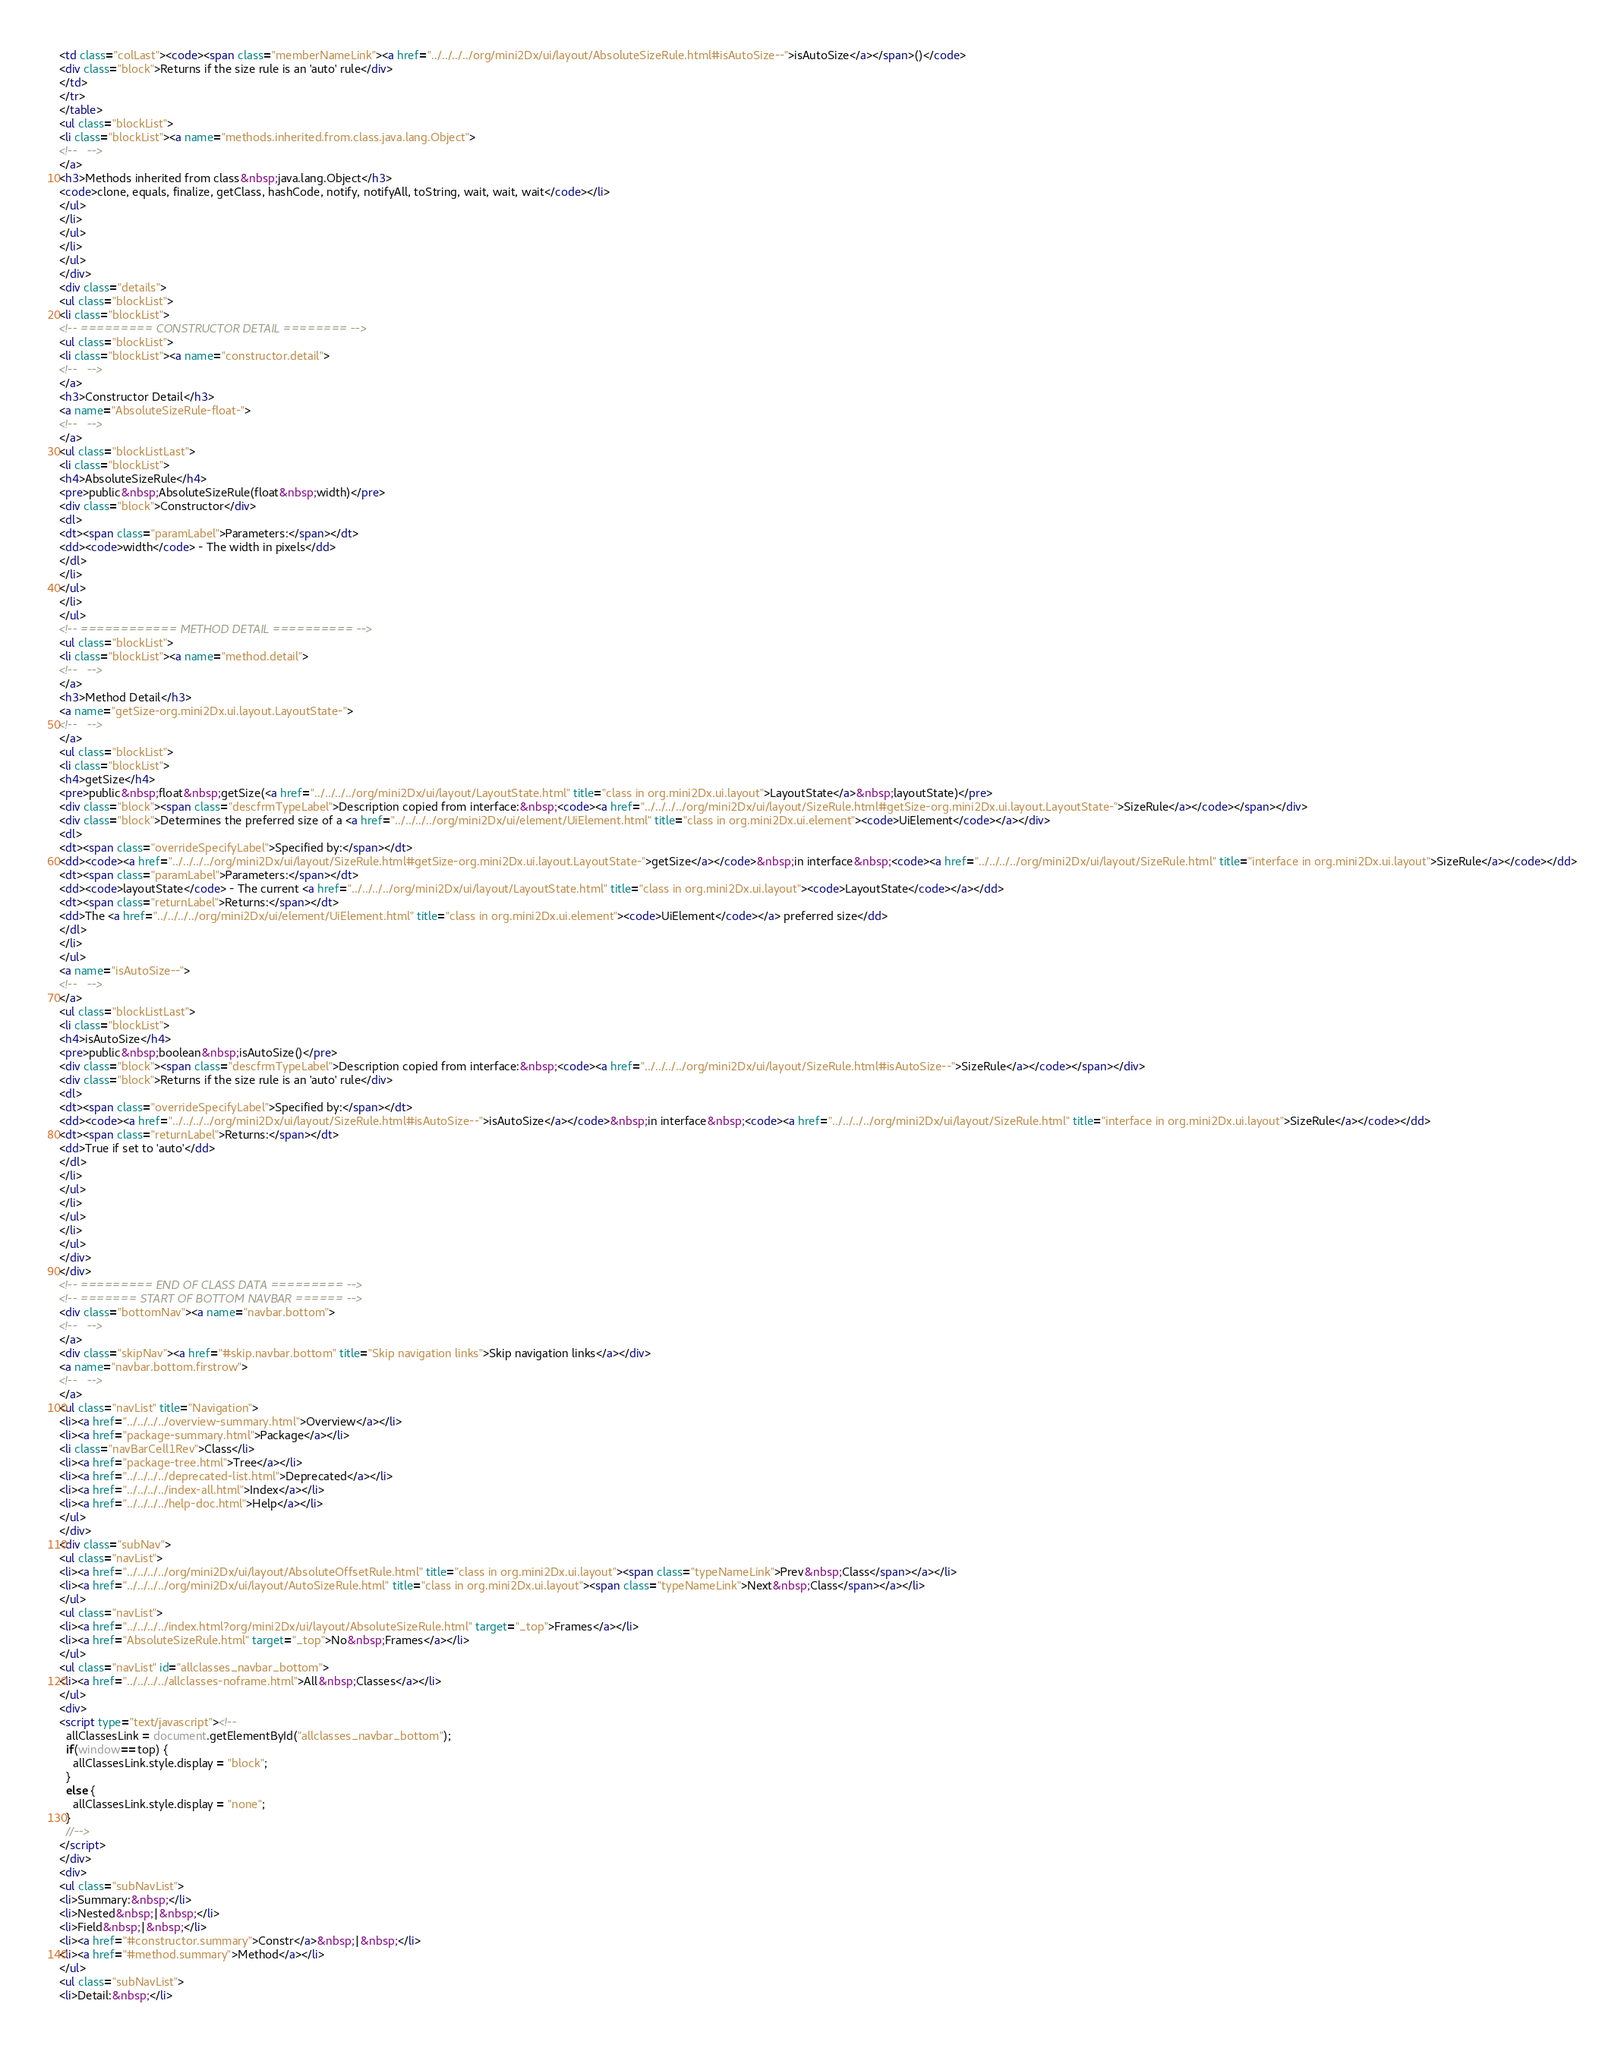<code> <loc_0><loc_0><loc_500><loc_500><_HTML_><td class="colLast"><code><span class="memberNameLink"><a href="../../../../org/mini2Dx/ui/layout/AbsoluteSizeRule.html#isAutoSize--">isAutoSize</a></span>()</code>
<div class="block">Returns if the size rule is an 'auto' rule</div>
</td>
</tr>
</table>
<ul class="blockList">
<li class="blockList"><a name="methods.inherited.from.class.java.lang.Object">
<!--   -->
</a>
<h3>Methods inherited from class&nbsp;java.lang.Object</h3>
<code>clone, equals, finalize, getClass, hashCode, notify, notifyAll, toString, wait, wait, wait</code></li>
</ul>
</li>
</ul>
</li>
</ul>
</div>
<div class="details">
<ul class="blockList">
<li class="blockList">
<!-- ========= CONSTRUCTOR DETAIL ======== -->
<ul class="blockList">
<li class="blockList"><a name="constructor.detail">
<!--   -->
</a>
<h3>Constructor Detail</h3>
<a name="AbsoluteSizeRule-float-">
<!--   -->
</a>
<ul class="blockListLast">
<li class="blockList">
<h4>AbsoluteSizeRule</h4>
<pre>public&nbsp;AbsoluteSizeRule(float&nbsp;width)</pre>
<div class="block">Constructor</div>
<dl>
<dt><span class="paramLabel">Parameters:</span></dt>
<dd><code>width</code> - The width in pixels</dd>
</dl>
</li>
</ul>
</li>
</ul>
<!-- ============ METHOD DETAIL ========== -->
<ul class="blockList">
<li class="blockList"><a name="method.detail">
<!--   -->
</a>
<h3>Method Detail</h3>
<a name="getSize-org.mini2Dx.ui.layout.LayoutState-">
<!--   -->
</a>
<ul class="blockList">
<li class="blockList">
<h4>getSize</h4>
<pre>public&nbsp;float&nbsp;getSize(<a href="../../../../org/mini2Dx/ui/layout/LayoutState.html" title="class in org.mini2Dx.ui.layout">LayoutState</a>&nbsp;layoutState)</pre>
<div class="block"><span class="descfrmTypeLabel">Description copied from interface:&nbsp;<code><a href="../../../../org/mini2Dx/ui/layout/SizeRule.html#getSize-org.mini2Dx.ui.layout.LayoutState-">SizeRule</a></code></span></div>
<div class="block">Determines the preferred size of a <a href="../../../../org/mini2Dx/ui/element/UiElement.html" title="class in org.mini2Dx.ui.element"><code>UiElement</code></a></div>
<dl>
<dt><span class="overrideSpecifyLabel">Specified by:</span></dt>
<dd><code><a href="../../../../org/mini2Dx/ui/layout/SizeRule.html#getSize-org.mini2Dx.ui.layout.LayoutState-">getSize</a></code>&nbsp;in interface&nbsp;<code><a href="../../../../org/mini2Dx/ui/layout/SizeRule.html" title="interface in org.mini2Dx.ui.layout">SizeRule</a></code></dd>
<dt><span class="paramLabel">Parameters:</span></dt>
<dd><code>layoutState</code> - The current <a href="../../../../org/mini2Dx/ui/layout/LayoutState.html" title="class in org.mini2Dx.ui.layout"><code>LayoutState</code></a></dd>
<dt><span class="returnLabel">Returns:</span></dt>
<dd>The <a href="../../../../org/mini2Dx/ui/element/UiElement.html" title="class in org.mini2Dx.ui.element"><code>UiElement</code></a> preferred size</dd>
</dl>
</li>
</ul>
<a name="isAutoSize--">
<!--   -->
</a>
<ul class="blockListLast">
<li class="blockList">
<h4>isAutoSize</h4>
<pre>public&nbsp;boolean&nbsp;isAutoSize()</pre>
<div class="block"><span class="descfrmTypeLabel">Description copied from interface:&nbsp;<code><a href="../../../../org/mini2Dx/ui/layout/SizeRule.html#isAutoSize--">SizeRule</a></code></span></div>
<div class="block">Returns if the size rule is an 'auto' rule</div>
<dl>
<dt><span class="overrideSpecifyLabel">Specified by:</span></dt>
<dd><code><a href="../../../../org/mini2Dx/ui/layout/SizeRule.html#isAutoSize--">isAutoSize</a></code>&nbsp;in interface&nbsp;<code><a href="../../../../org/mini2Dx/ui/layout/SizeRule.html" title="interface in org.mini2Dx.ui.layout">SizeRule</a></code></dd>
<dt><span class="returnLabel">Returns:</span></dt>
<dd>True if set to 'auto'</dd>
</dl>
</li>
</ul>
</li>
</ul>
</li>
</ul>
</div>
</div>
<!-- ========= END OF CLASS DATA ========= -->
<!-- ======= START OF BOTTOM NAVBAR ====== -->
<div class="bottomNav"><a name="navbar.bottom">
<!--   -->
</a>
<div class="skipNav"><a href="#skip.navbar.bottom" title="Skip navigation links">Skip navigation links</a></div>
<a name="navbar.bottom.firstrow">
<!--   -->
</a>
<ul class="navList" title="Navigation">
<li><a href="../../../../overview-summary.html">Overview</a></li>
<li><a href="package-summary.html">Package</a></li>
<li class="navBarCell1Rev">Class</li>
<li><a href="package-tree.html">Tree</a></li>
<li><a href="../../../../deprecated-list.html">Deprecated</a></li>
<li><a href="../../../../index-all.html">Index</a></li>
<li><a href="../../../../help-doc.html">Help</a></li>
</ul>
</div>
<div class="subNav">
<ul class="navList">
<li><a href="../../../../org/mini2Dx/ui/layout/AbsoluteOffsetRule.html" title="class in org.mini2Dx.ui.layout"><span class="typeNameLink">Prev&nbsp;Class</span></a></li>
<li><a href="../../../../org/mini2Dx/ui/layout/AutoSizeRule.html" title="class in org.mini2Dx.ui.layout"><span class="typeNameLink">Next&nbsp;Class</span></a></li>
</ul>
<ul class="navList">
<li><a href="../../../../index.html?org/mini2Dx/ui/layout/AbsoluteSizeRule.html" target="_top">Frames</a></li>
<li><a href="AbsoluteSizeRule.html" target="_top">No&nbsp;Frames</a></li>
</ul>
<ul class="navList" id="allclasses_navbar_bottom">
<li><a href="../../../../allclasses-noframe.html">All&nbsp;Classes</a></li>
</ul>
<div>
<script type="text/javascript"><!--
  allClassesLink = document.getElementById("allclasses_navbar_bottom");
  if(window==top) {
    allClassesLink.style.display = "block";
  }
  else {
    allClassesLink.style.display = "none";
  }
  //-->
</script>
</div>
<div>
<ul class="subNavList">
<li>Summary:&nbsp;</li>
<li>Nested&nbsp;|&nbsp;</li>
<li>Field&nbsp;|&nbsp;</li>
<li><a href="#constructor.summary">Constr</a>&nbsp;|&nbsp;</li>
<li><a href="#method.summary">Method</a></li>
</ul>
<ul class="subNavList">
<li>Detail:&nbsp;</li></code> 